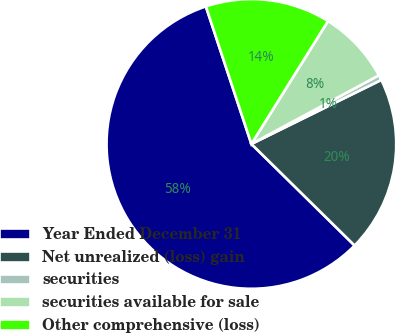Convert chart. <chart><loc_0><loc_0><loc_500><loc_500><pie_chart><fcel>Year Ended December 31<fcel>Net unrealized (loss) gain<fcel>securities<fcel>securities available for sale<fcel>Other comprehensive (loss)<nl><fcel>57.54%<fcel>19.66%<fcel>0.57%<fcel>8.27%<fcel>13.96%<nl></chart> 